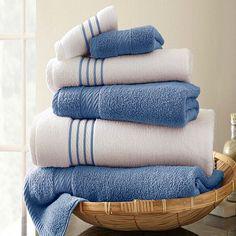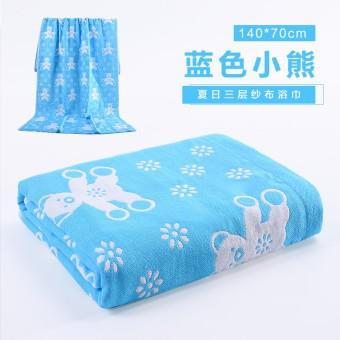The first image is the image on the left, the second image is the image on the right. Analyze the images presented: Is the assertion "A stack of three or more towels has folded washcloths on top." valid? Answer yes or no. Yes. The first image is the image on the left, the second image is the image on the right. Given the left and right images, does the statement "There are four towels on the left and three towels on the right, all folded neatly" hold true? Answer yes or no. No. 